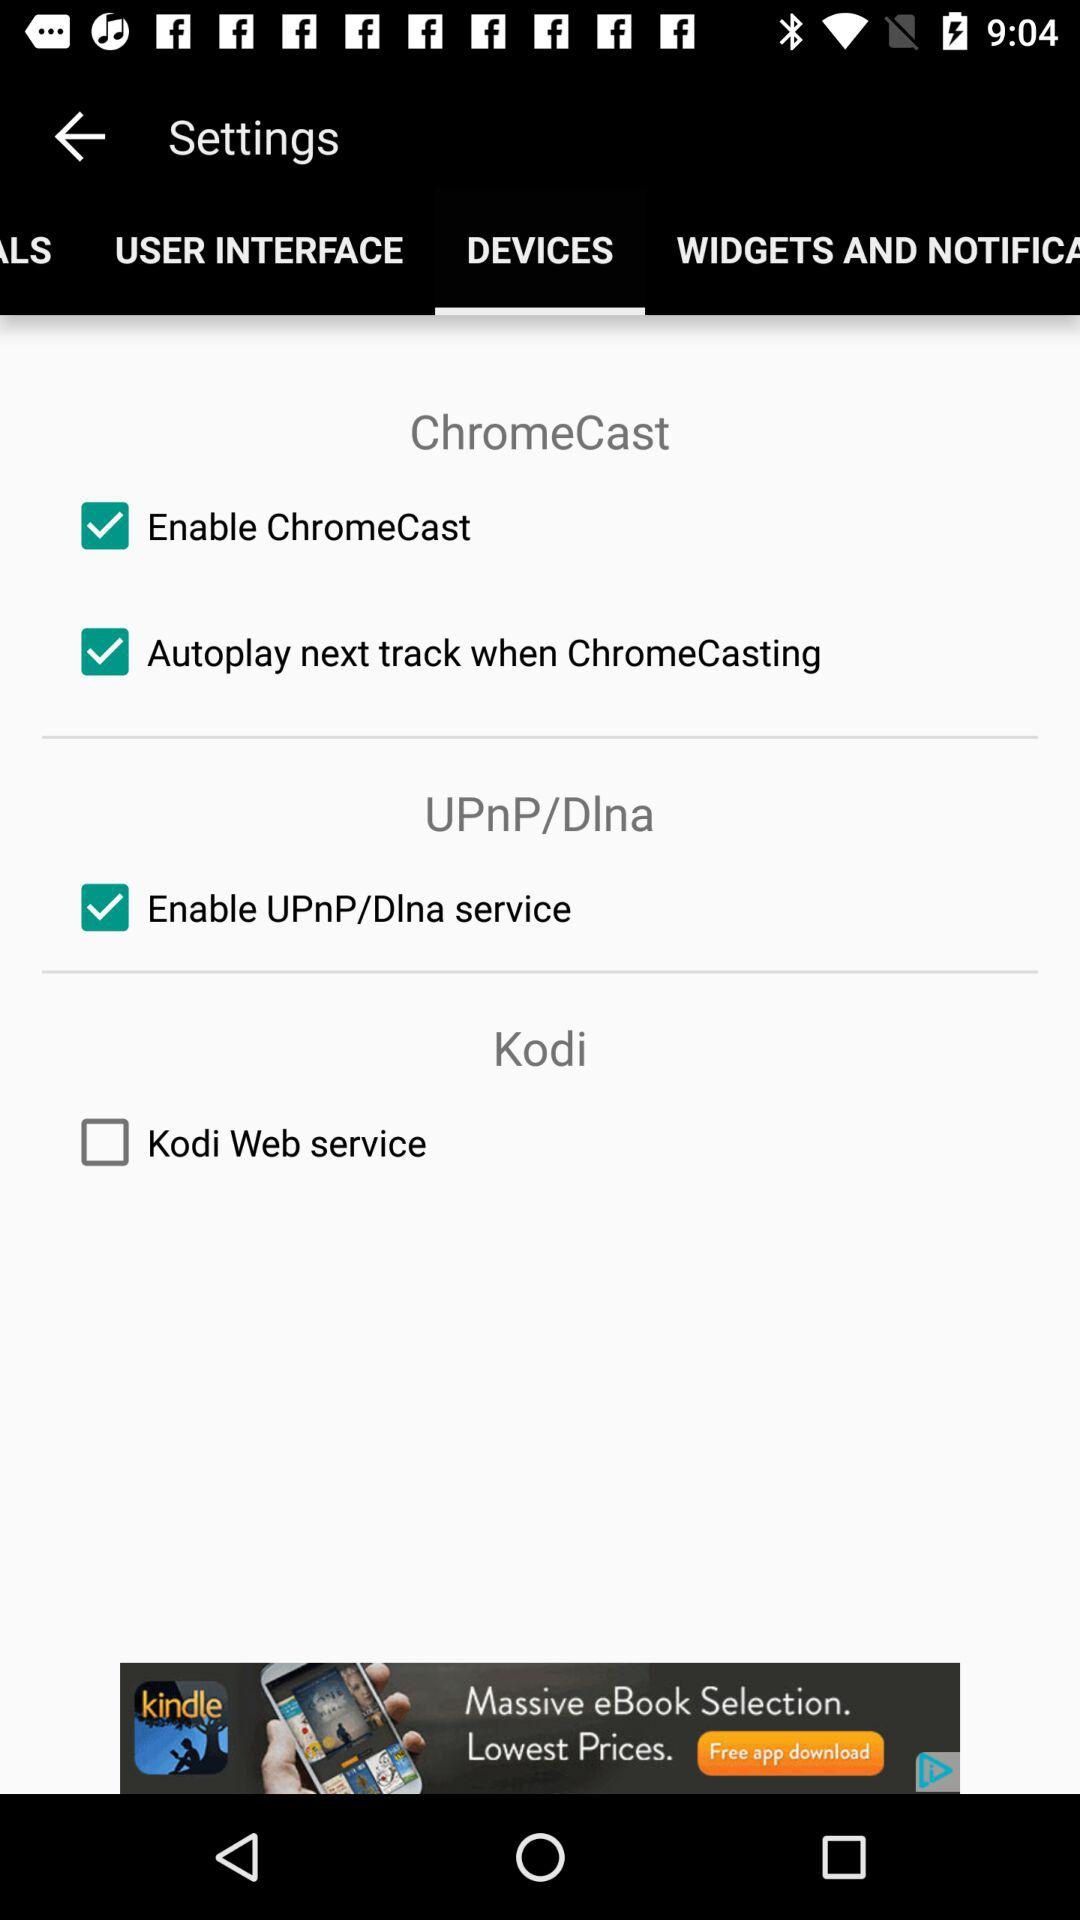What is the current status of the "Kodi Web service"? The status is "off". 